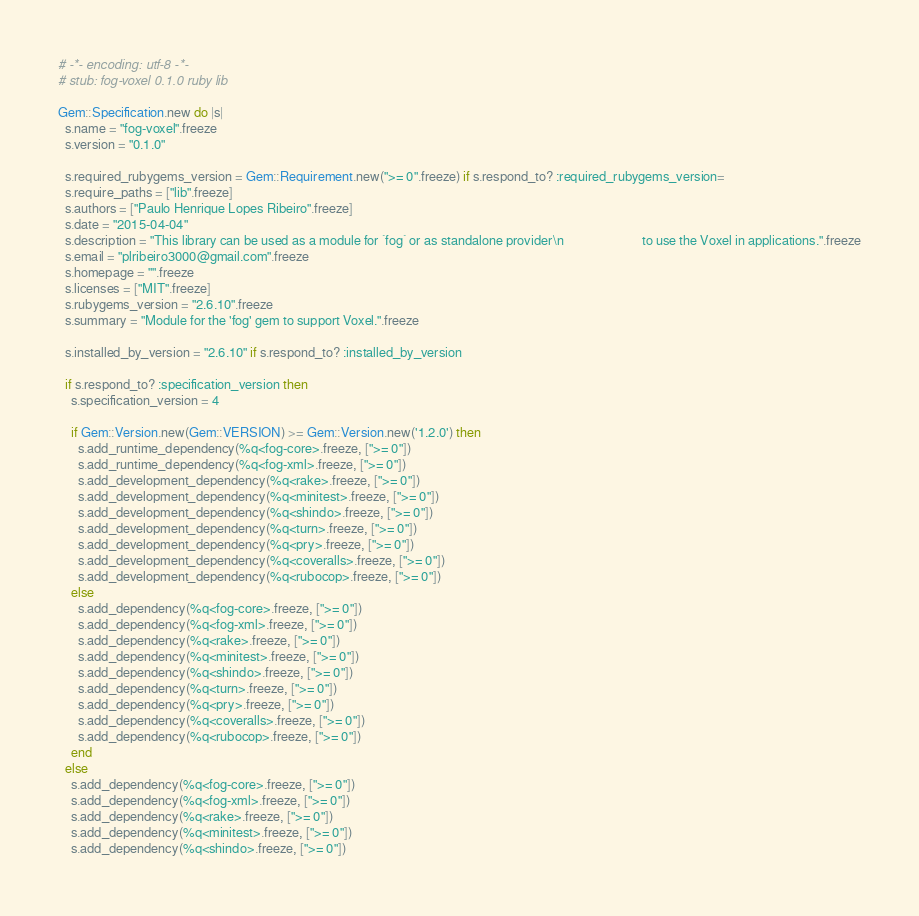Convert code to text. <code><loc_0><loc_0><loc_500><loc_500><_Ruby_># -*- encoding: utf-8 -*-
# stub: fog-voxel 0.1.0 ruby lib

Gem::Specification.new do |s|
  s.name = "fog-voxel".freeze
  s.version = "0.1.0"

  s.required_rubygems_version = Gem::Requirement.new(">= 0".freeze) if s.respond_to? :required_rubygems_version=
  s.require_paths = ["lib".freeze]
  s.authors = ["Paulo Henrique Lopes Ribeiro".freeze]
  s.date = "2015-04-04"
  s.description = "This library can be used as a module for `fog` or as standalone provider\n                        to use the Voxel in applications.".freeze
  s.email = "plribeiro3000@gmail.com".freeze
  s.homepage = "".freeze
  s.licenses = ["MIT".freeze]
  s.rubygems_version = "2.6.10".freeze
  s.summary = "Module for the 'fog' gem to support Voxel.".freeze

  s.installed_by_version = "2.6.10" if s.respond_to? :installed_by_version

  if s.respond_to? :specification_version then
    s.specification_version = 4

    if Gem::Version.new(Gem::VERSION) >= Gem::Version.new('1.2.0') then
      s.add_runtime_dependency(%q<fog-core>.freeze, [">= 0"])
      s.add_runtime_dependency(%q<fog-xml>.freeze, [">= 0"])
      s.add_development_dependency(%q<rake>.freeze, [">= 0"])
      s.add_development_dependency(%q<minitest>.freeze, [">= 0"])
      s.add_development_dependency(%q<shindo>.freeze, [">= 0"])
      s.add_development_dependency(%q<turn>.freeze, [">= 0"])
      s.add_development_dependency(%q<pry>.freeze, [">= 0"])
      s.add_development_dependency(%q<coveralls>.freeze, [">= 0"])
      s.add_development_dependency(%q<rubocop>.freeze, [">= 0"])
    else
      s.add_dependency(%q<fog-core>.freeze, [">= 0"])
      s.add_dependency(%q<fog-xml>.freeze, [">= 0"])
      s.add_dependency(%q<rake>.freeze, [">= 0"])
      s.add_dependency(%q<minitest>.freeze, [">= 0"])
      s.add_dependency(%q<shindo>.freeze, [">= 0"])
      s.add_dependency(%q<turn>.freeze, [">= 0"])
      s.add_dependency(%q<pry>.freeze, [">= 0"])
      s.add_dependency(%q<coveralls>.freeze, [">= 0"])
      s.add_dependency(%q<rubocop>.freeze, [">= 0"])
    end
  else
    s.add_dependency(%q<fog-core>.freeze, [">= 0"])
    s.add_dependency(%q<fog-xml>.freeze, [">= 0"])
    s.add_dependency(%q<rake>.freeze, [">= 0"])
    s.add_dependency(%q<minitest>.freeze, [">= 0"])
    s.add_dependency(%q<shindo>.freeze, [">= 0"])</code> 